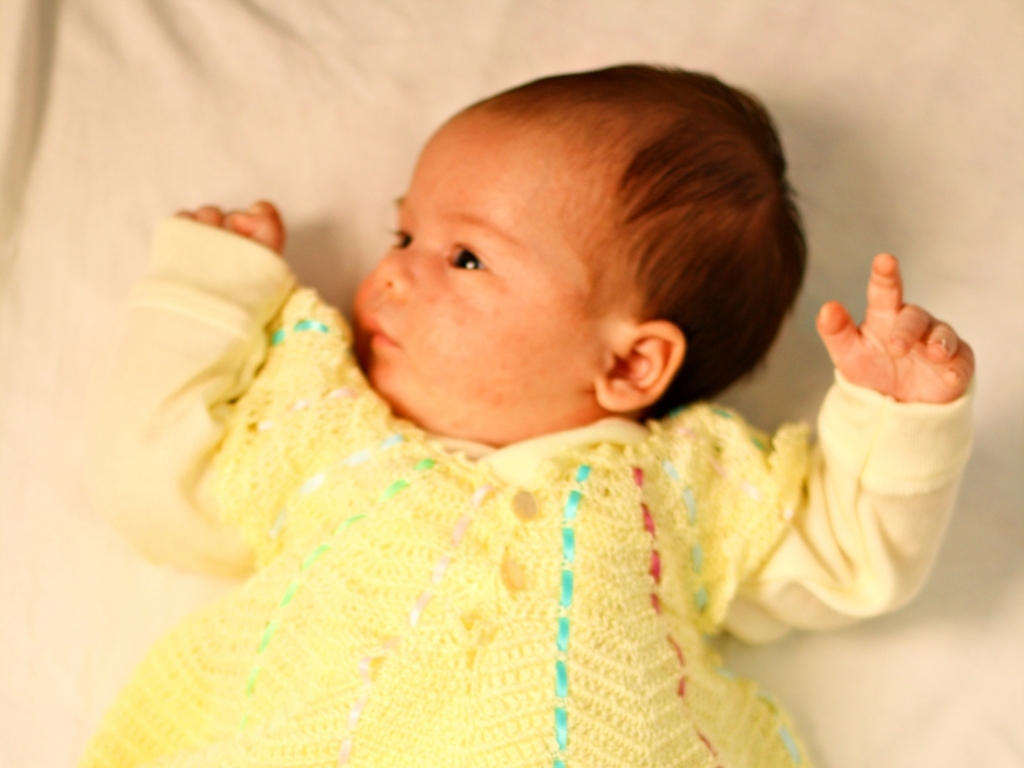Can you describe the details of the clothing? Certainly, the infant is dressed in a knitted yellow garment with hints of blue and purple thread running through it. The patterns indicate a handcrafted design, while the loose-fitting sleeves suggest comfort and ease of movement for the baby. Does the style of clothing suggest anything about the occasion? The handmade style of the clothing may imply a special occasion, such as a family gathering or a photoshoot to commemorate the early stages of the infant's life. It exudes a personal touch that's often cherished in such memorable moments. 